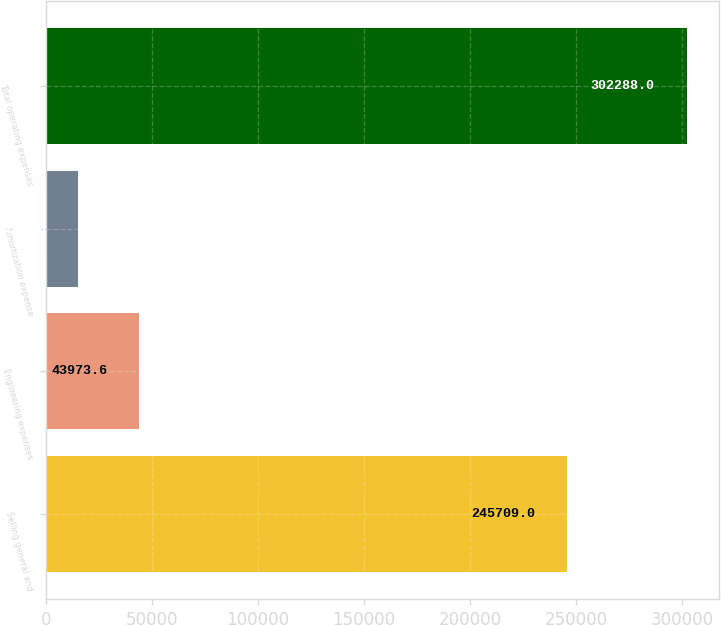<chart> <loc_0><loc_0><loc_500><loc_500><bar_chart><fcel>Selling general and<fcel>Engineering expenses<fcel>Amortization expense<fcel>Total operating expenses<nl><fcel>245709<fcel>43973.6<fcel>15272<fcel>302288<nl></chart> 